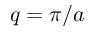<formula> <loc_0><loc_0><loc_500><loc_500>q = \pi / a</formula> 